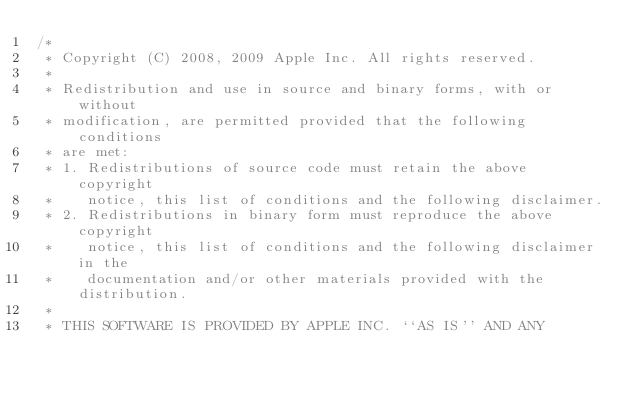<code> <loc_0><loc_0><loc_500><loc_500><_C++_>/*
 * Copyright (C) 2008, 2009 Apple Inc. All rights reserved.
 *
 * Redistribution and use in source and binary forms, with or without
 * modification, are permitted provided that the following conditions
 * are met:
 * 1. Redistributions of source code must retain the above copyright
 *    notice, this list of conditions and the following disclaimer.
 * 2. Redistributions in binary form must reproduce the above copyright
 *    notice, this list of conditions and the following disclaimer in the
 *    documentation and/or other materials provided with the distribution.
 *
 * THIS SOFTWARE IS PROVIDED BY APPLE INC. ``AS IS'' AND ANY</code> 